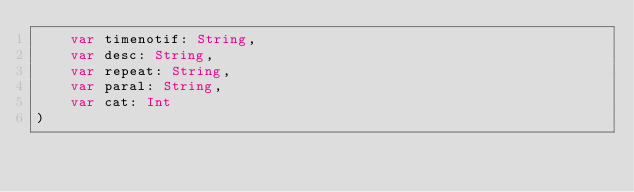<code> <loc_0><loc_0><loc_500><loc_500><_Kotlin_>    var timenotif: String,
    var desc: String,
    var repeat: String,
    var paral: String,
    var cat: Int
)</code> 